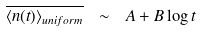<formula> <loc_0><loc_0><loc_500><loc_500>\overline { \left \langle n ( t ) \right \rangle _ { u n i f o r m } } \ \sim \ A + B \log t</formula> 